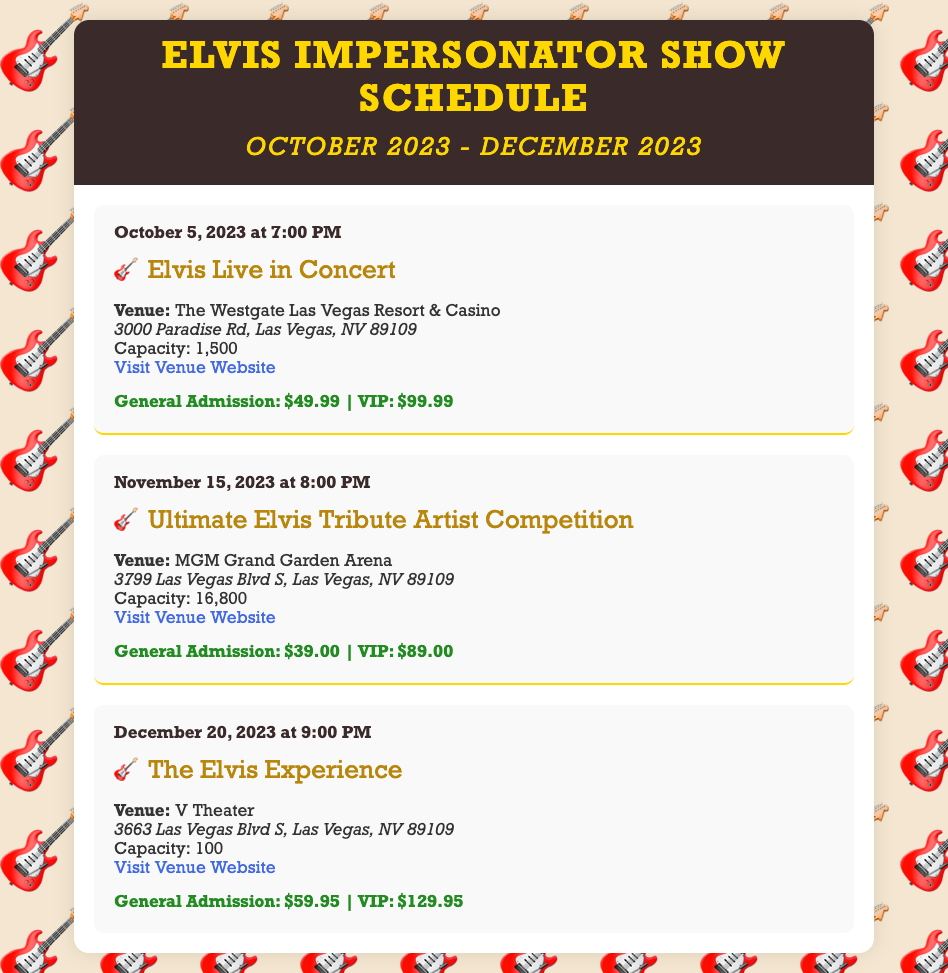what is the date of the first show? The first show is scheduled for October 5, 2023.
Answer: October 5, 2023 where is the Ultimate Elvis Tribute Artist Competition being held? The competition is taking place at MGM Grand Garden Arena.
Answer: MGM Grand Garden Arena what is the ticket price for VIP seating at The Elvis Experience? The VIP ticket price for The Elvis Experience is $129.95.
Answer: $129.95 how many seats does V Theater have? V Theater has a capacity of 100 seats.
Answer: 100 what time does the show on December 20, 2023 start? The show on December 20, 2023 starts at 9:00 PM.
Answer: 9:00 PM which venue has the largest capacity? The venue with the largest capacity is MGM Grand Garden Arena with 16,800 seats.
Answer: MGM Grand Garden Arena what is the general admission price for the show on November 15, 2023? The general admission price for the show on November 15, 2023 is $39.00.
Answer: $39.00 who is performing on October 5, 2023? The performer on October 5, 2023 is Elvis Live in Concert.
Answer: Elvis Live in Concert 